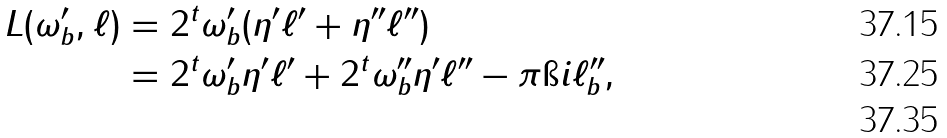<formula> <loc_0><loc_0><loc_500><loc_500>L ( \omega _ { b } ^ { \prime } , \ell ) & = 2 ^ { t } \omega _ { b } ^ { \prime } ( \eta ^ { \prime } \ell ^ { \prime } + \eta ^ { \prime \prime } \ell ^ { \prime \prime } ) \\ & = 2 ^ { t } \omega _ { b } ^ { \prime } \eta ^ { \prime } \ell ^ { \prime } + 2 ^ { t } \omega _ { b } ^ { \prime \prime } \eta ^ { \prime } \ell ^ { \prime \prime } - \pi \i i \ell ^ { \prime \prime } _ { b } , \\</formula> 